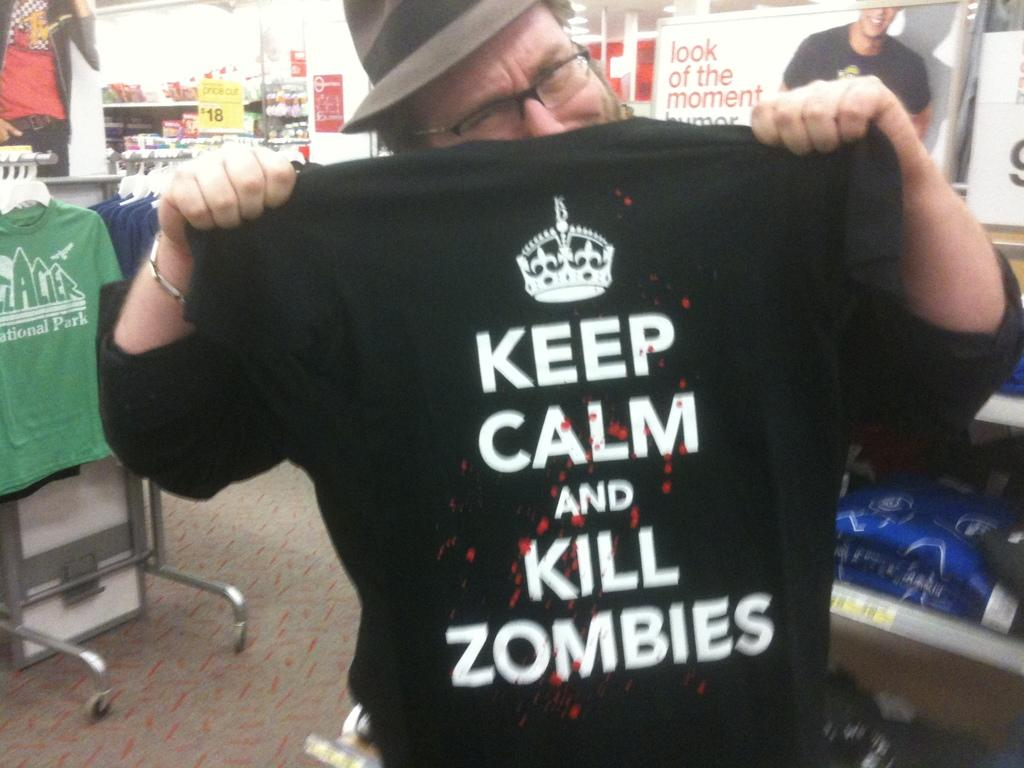Who is present in the image? There is a person in the image. What is the person holding in his hand? The person is holding a T-shirt in his hand. Can you describe the setting of the image? The background setting appears to be a store. What other items can be seen in the image? There are other items visible in the background of the image. What type of plastic fang can be seen in the person's mouth in the image? There is no plastic fang visible in the person's mouth in the image. 